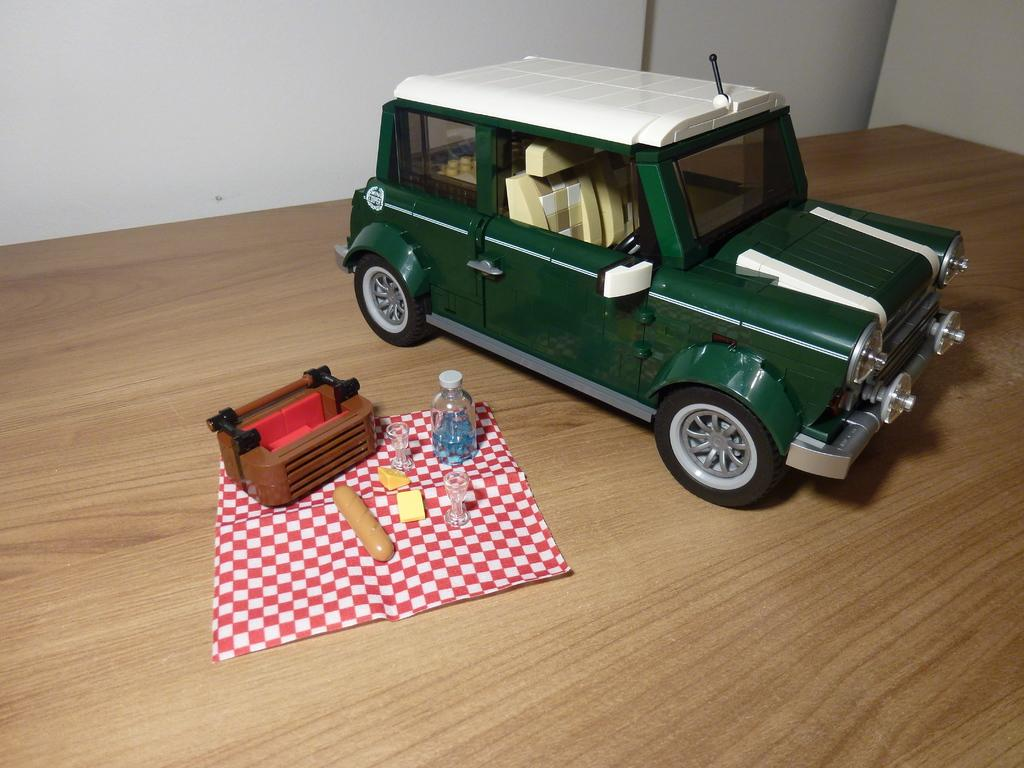What type of toy is present in the image? There is a toy car in the image. What is the toy car placed on? There is a mat in the image. What is the bottle used for in the image? The purpose of the bottle is not specified, but it is present in the image. What can be seen on the table in the image? There are objects on a table in the image. What is visible in the background of the image? There is a wall in the background of the image. How many snakes are slithering on the table in the image? There are no snakes present in the image; it only features a toy car, mat, bottle, table, and wall. Is there a spy observing the scene in the image? There is no indication of a spy or any person in the image; it only shows objects and a wall in the background. 